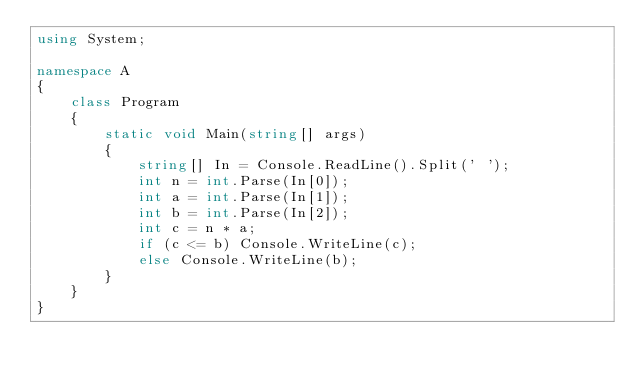<code> <loc_0><loc_0><loc_500><loc_500><_C#_>using System;

namespace A
{
    class Program
    {
        static void Main(string[] args)
        {
            string[] In = Console.ReadLine().Split(' ');
            int n = int.Parse(In[0]);
            int a = int.Parse(In[1]);
            int b = int.Parse(In[2]);
            int c = n * a;
            if (c <= b) Console.WriteLine(c);
            else Console.WriteLine(b);
        }
    }
}
</code> 